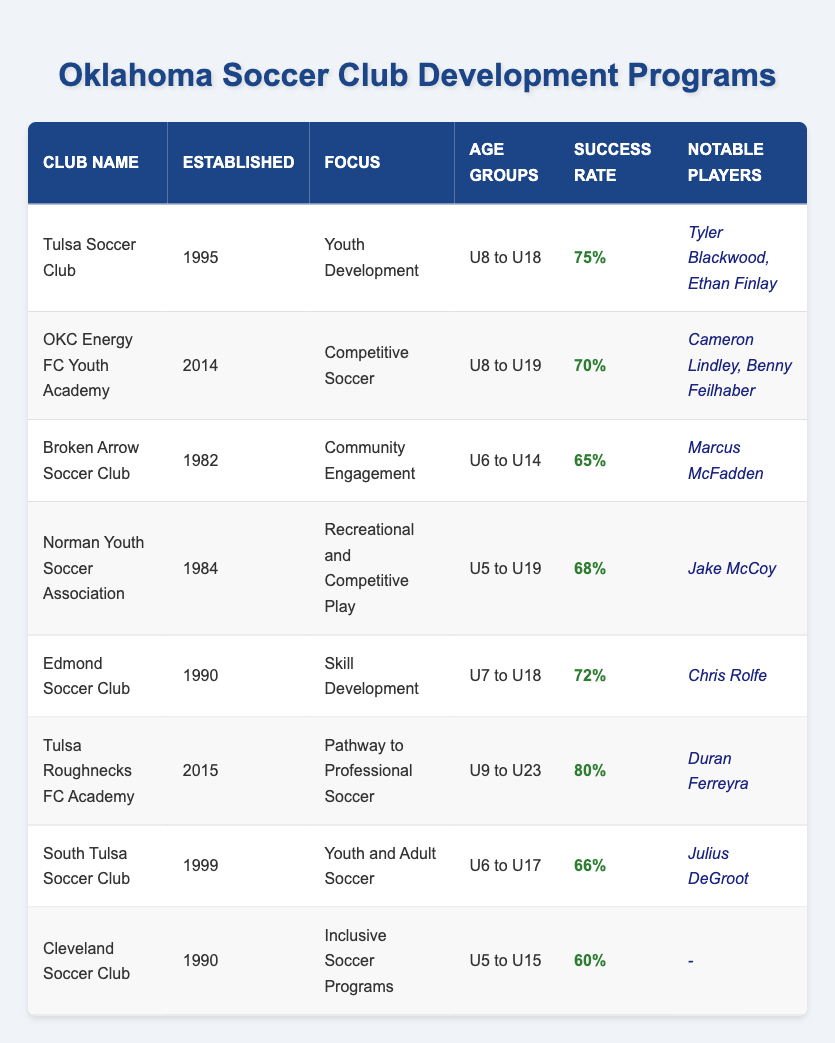What is the success rate of Tulsa Roughnecks FC Academy? According to the table, the success rate listed for Tulsa Roughnecks FC Academy is 80%.
Answer: 80% What year was the Broken Arrow Soccer Club established? The table indicates that Broken Arrow Soccer Club was established in 1982.
Answer: 1982 Which club has a focus on Community Engagement? The table shows that the Broken Arrow Soccer Club has a focus on Community Engagement.
Answer: Broken Arrow Soccer Club How many notable players are listed for Cleveland Soccer Club? The table indicates that Cleveland Soccer Club has no notable players listed, as shown by the dash in the corresponding cell.
Answer: 0 Which club has the highest success rate and what is that rate? By examining the success rates, Tulsa Roughnecks FC Academy has the highest rate at 80%, while the other clubs have lower rates ranging from 60% to 75%.
Answer: Tulsa Roughnecks FC Academy; 80% What is the average success rate of clubs established before 1990? The clubs established before 1990 and their success rates are: Broken Arrow Soccer Club (65%), Norman Youth Soccer Association (68%), Edmond Soccer Club (72%), and Tulsa Soccer Club (75%). The average can be calculated by taking the sum of these rates (65 + 68 + 72 + 75) = 280. Then divide by the number of clubs, 4, which gives us 280/4 = 70%.
Answer: 70% Is there any club on the table that has a success rate below 65%? By reviewing the table, the club with a success rate below 65% is Cleveland Soccer Club, which has a success rate of 60%.
Answer: Yes How many clubs offer programs for age groups U6 to U14? The clubs that offer programs for the age groups U6 to U14 according to the table are Broken Arrow Soccer Club and South Tulsa Soccer Club, which makes a total of 2 clubs.
Answer: 2 